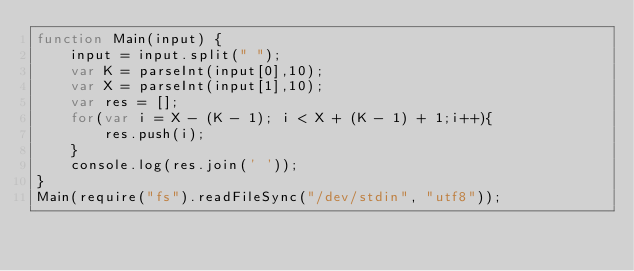<code> <loc_0><loc_0><loc_500><loc_500><_JavaScript_>function Main(input) {
    input = input.split(" ");
    var K = parseInt(input[0],10);
    var X = parseInt(input[1],10);
    var res = [];
    for(var i = X - (K - 1); i < X + (K - 1) + 1;i++){
        res.push(i);
    }
    console.log(res.join(' '));
}
Main(require("fs").readFileSync("/dev/stdin", "utf8"));</code> 